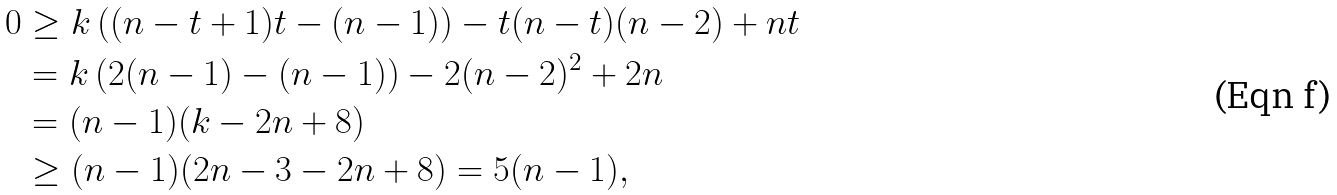<formula> <loc_0><loc_0><loc_500><loc_500>0 & \geq k \left ( ( n - t + 1 ) t - ( n - 1 ) \right ) - t ( n - t ) ( n - 2 ) + n t \\ & = k \left ( 2 ( n - 1 ) - ( n - 1 ) \right ) - 2 ( n - 2 ) ^ { 2 } + 2 n \\ & = ( n - 1 ) ( k - 2 n + 8 ) \\ & \geq ( n - 1 ) ( 2 n - 3 - 2 n + 8 ) = 5 ( n - 1 ) ,</formula> 